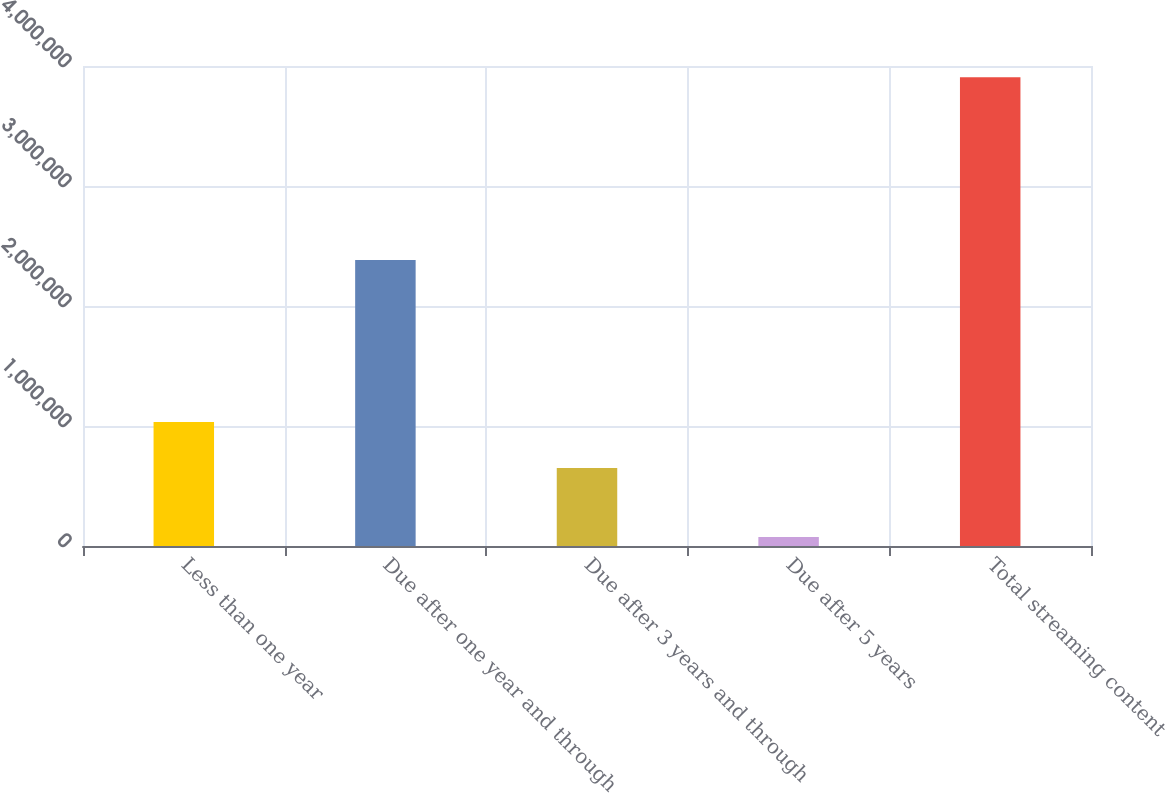Convert chart. <chart><loc_0><loc_0><loc_500><loc_500><bar_chart><fcel>Less than one year<fcel>Due after one year and through<fcel>Due after 3 years and through<fcel>Due after 5 years<fcel>Total streaming content<nl><fcel>1.03373e+06<fcel>2.38437e+06<fcel>650480<fcel>74696<fcel>3.9072e+06<nl></chart> 